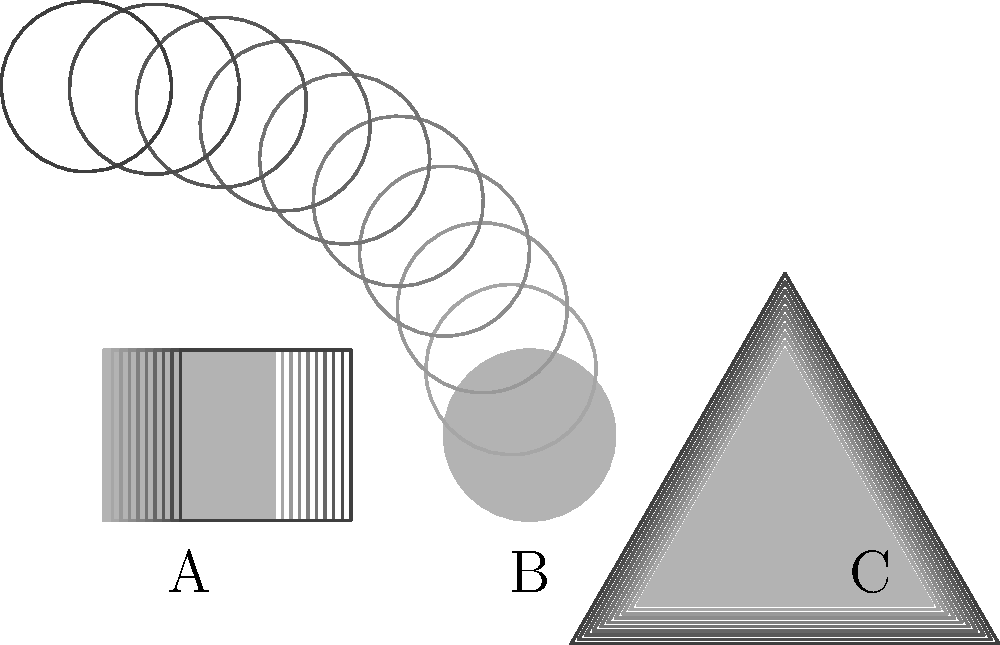Identify the types of motion blur effects applied to each geometric shape in the image. Match the letters A, B, and C with the corresponding motion blur effect: linear, radial, or zoom. To identify the motion blur effects, let's analyze each shape:

1. Shape A (Square):
   - The blur effect shows a horizontal smearing of the shape.
   - This indicates movement in a straight line from left to right.
   - This type of blur is characteristic of linear motion blur.

2. Shape B (Circle):
   - The blur effect shows a circular smearing around the shape's center.
   - This suggests rotation around a central point.
   - This type of blur is characteristic of radial motion blur.

3. Shape C (Triangle):
   - The blur effect shows the shape expanding outward from its center.
   - This indicates a movement that appears to be coming towards the viewer.
   - This type of blur is characteristic of zoom motion blur.

Therefore, the correct matching is:
A - Linear motion blur
B - Radial motion blur
C - Zoom motion blur
Answer: A: Linear, B: Radial, C: Zoom 